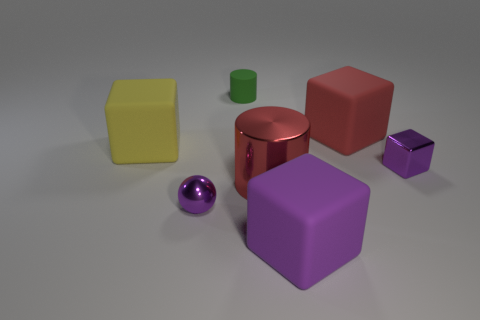Add 2 small purple rubber balls. How many objects exist? 9 Subtract 1 green cylinders. How many objects are left? 6 Subtract all cylinders. How many objects are left? 5 Subtract 2 blocks. How many blocks are left? 2 Subtract all brown cylinders. Subtract all yellow balls. How many cylinders are left? 2 Subtract all gray cylinders. How many blue cubes are left? 0 Subtract all tiny purple things. Subtract all yellow objects. How many objects are left? 4 Add 4 yellow rubber blocks. How many yellow rubber blocks are left? 5 Add 2 small purple metallic balls. How many small purple metallic balls exist? 3 Subtract all red cylinders. How many cylinders are left? 1 